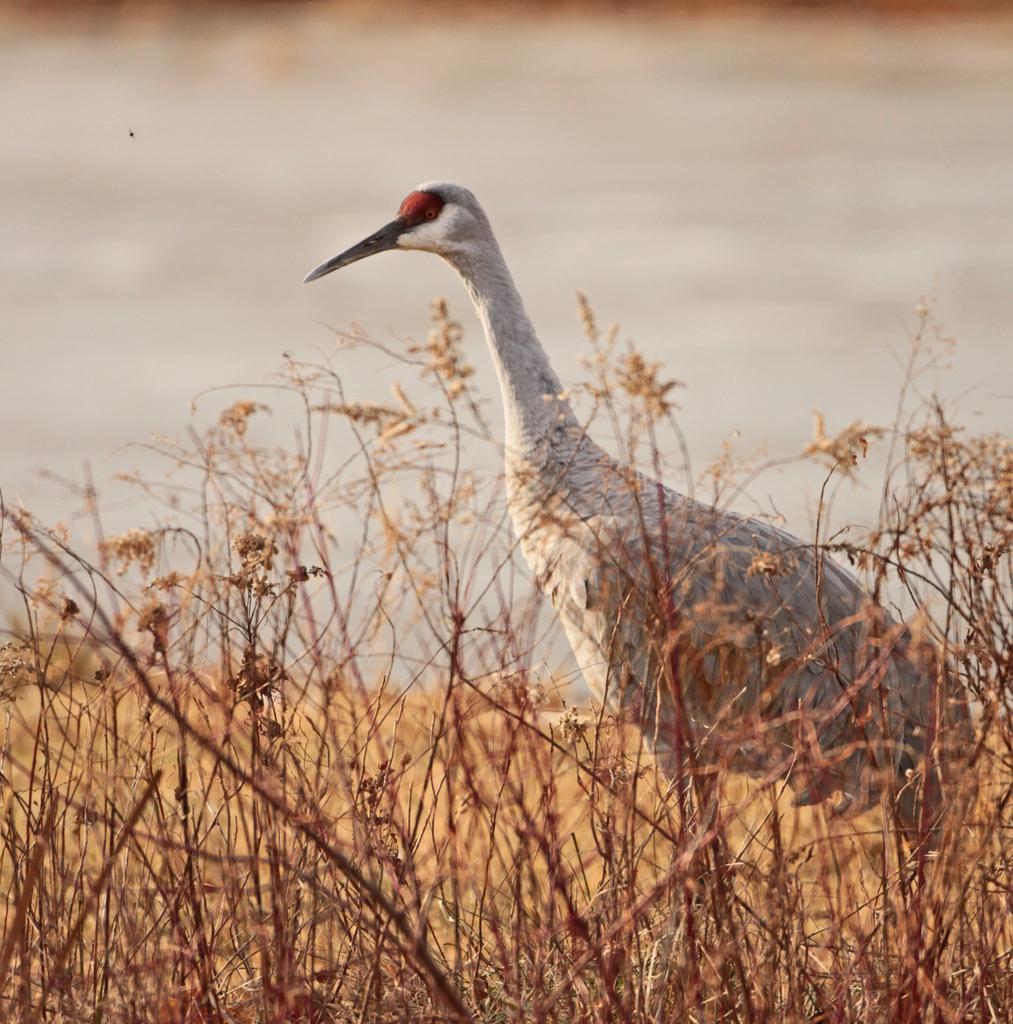How would you summarize this image in a sentence or two? In the image we can see a bird. Here we can see dry grass, water and the background is blurred. 